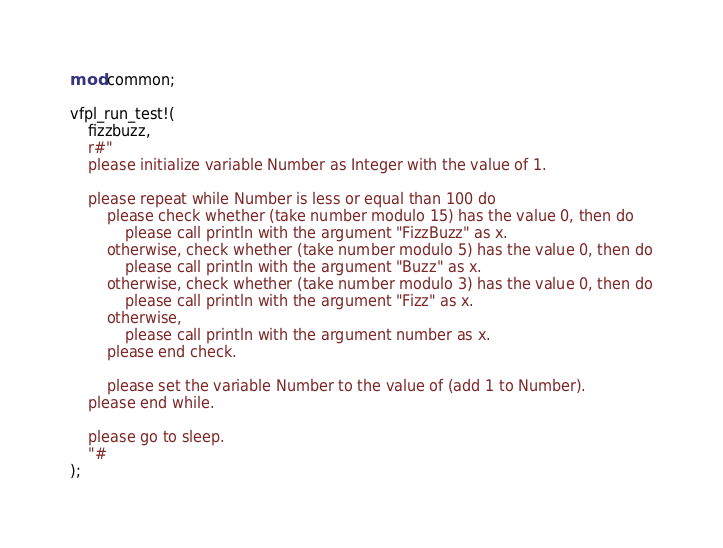Convert code to text. <code><loc_0><loc_0><loc_500><loc_500><_Rust_>mod common;

vfpl_run_test!(
    fizzbuzz,
    r#"
    please initialize variable Number as Integer with the value of 1.
    
    please repeat while Number is less or equal than 100 do
        please check whether (take number modulo 15) has the value 0, then do
            please call println with the argument "FizzBuzz" as x.
        otherwise, check whether (take number modulo 5) has the value 0, then do
            please call println with the argument "Buzz" as x.
        otherwise, check whether (take number modulo 3) has the value 0, then do
            please call println with the argument "Fizz" as x.
        otherwise,
            please call println with the argument number as x.
        please end check.
    
        please set the variable Number to the value of (add 1 to Number).
    please end while.
    
    please go to sleep.
    "#
);
</code> 